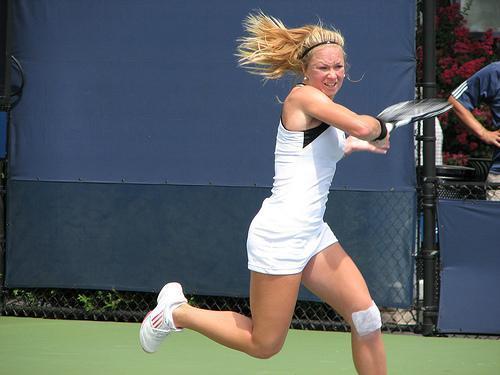How many players are in the picture?
Give a very brief answer. 1. 